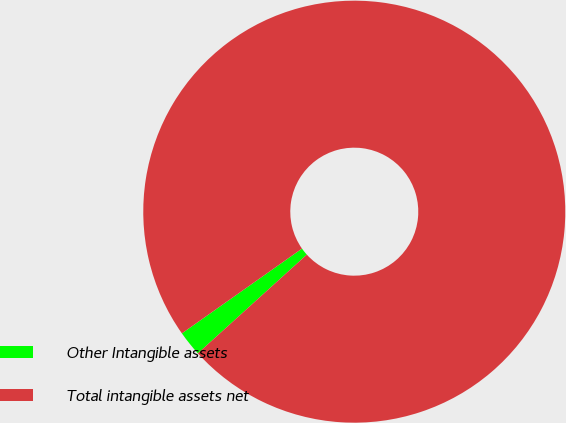<chart> <loc_0><loc_0><loc_500><loc_500><pie_chart><fcel>Other Intangible assets<fcel>Total intangible assets net<nl><fcel>1.93%<fcel>98.07%<nl></chart> 